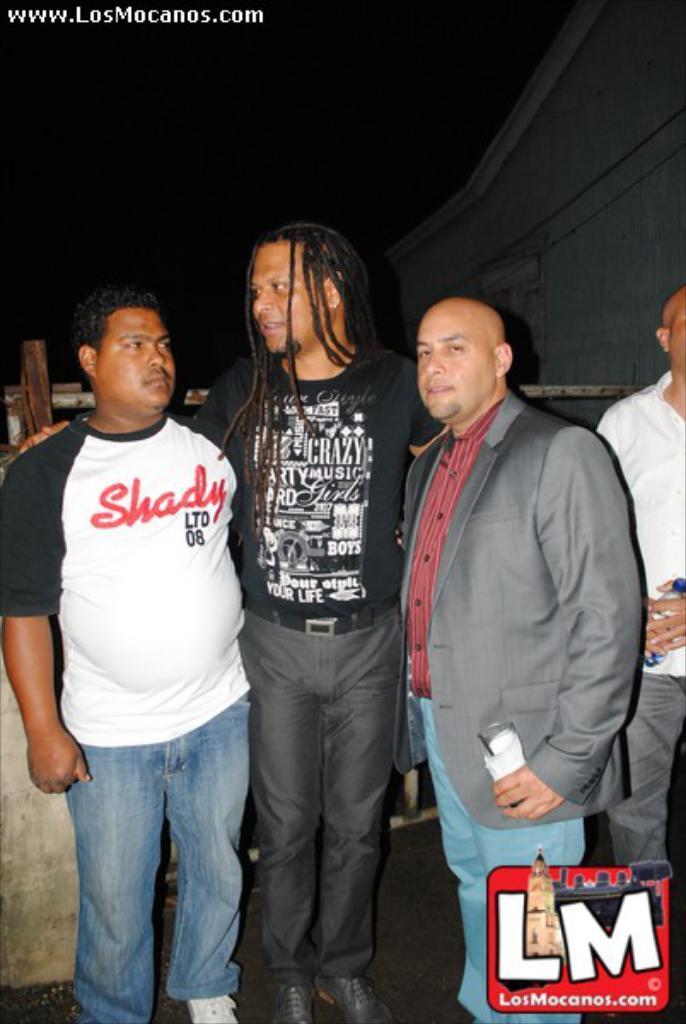Please provide a concise description of this image. In this image we can see a few people standing, among them some are holding the objects, on the right of the image we can see the wall, there is some text and poles, also we can see the background is dark. 